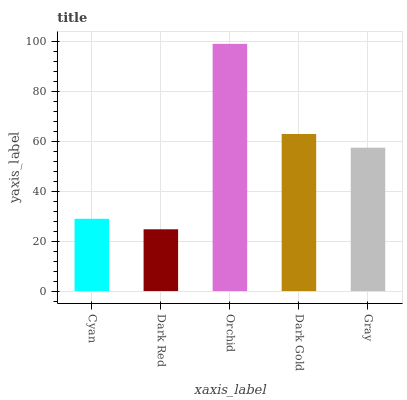Is Dark Red the minimum?
Answer yes or no. Yes. Is Orchid the maximum?
Answer yes or no. Yes. Is Orchid the minimum?
Answer yes or no. No. Is Dark Red the maximum?
Answer yes or no. No. Is Orchid greater than Dark Red?
Answer yes or no. Yes. Is Dark Red less than Orchid?
Answer yes or no. Yes. Is Dark Red greater than Orchid?
Answer yes or no. No. Is Orchid less than Dark Red?
Answer yes or no. No. Is Gray the high median?
Answer yes or no. Yes. Is Gray the low median?
Answer yes or no. Yes. Is Dark Gold the high median?
Answer yes or no. No. Is Cyan the low median?
Answer yes or no. No. 